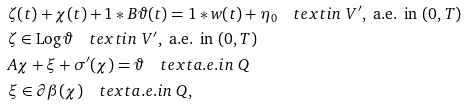Convert formula to latex. <formula><loc_0><loc_0><loc_500><loc_500>& \zeta ( t ) + \chi ( t ) + 1 \ast B \vartheta ( t ) = 1 \ast w ( t ) + \eta _ { 0 } \quad t e x t { i n } \ V ^ { \prime } , \ \text {a.e. in} \ ( 0 , T ) \\ & \zeta \in \text {Log} \, \vartheta \quad t e x t { i n } \ V ^ { \prime } , \ \text {a.e. in} \ ( 0 , T ) \\ & A \chi + \xi + \sigma ^ { \prime } ( \chi ) = \vartheta \quad t e x t { a . e . i n } \ Q \\ & \xi \in \partial \beta ( \chi ) \quad t e x t { a . e . i n } \ Q ,</formula> 